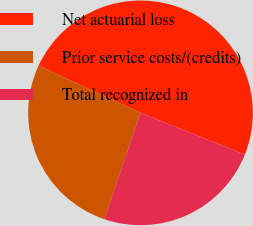<chart> <loc_0><loc_0><loc_500><loc_500><pie_chart><fcel>Net actuarial loss<fcel>Prior service costs/(credits)<fcel>Total recognized in<nl><fcel>49.16%<fcel>26.67%<fcel>24.17%<nl></chart> 